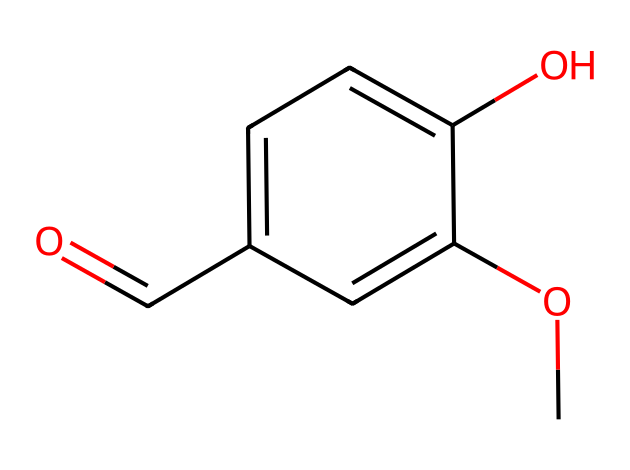What is the molecular formula of vanillin? By analyzing the chemical structure represented in the SMILES notation, we can identify the elements present: carbon (C), hydrogen (H), and oxygen (O). Counting the individual atoms, we find 8 carbon atoms, 8 hydrogen atoms, and 3 oxygen atoms, resulting in the molecular formula C8H8O3.
Answer: C8H8O3 How many aromatic rings are present in vanillin? Looking at the chemical structure, there is one distinct ring that contains alternating double bonds, which indicates it is an aromatic ring.
Answer: 1 What functional groups are present in vanillin? The SMILES representation indicates the presence of a methoxy group (–OCH3) and a hydroxyl group (–OH), both of which are characteristic functional groups found in the chemical structure of vanillin.
Answer: methoxy and hydroxyl What is the significance of the aldehyde group in vanillin? The presence of the aldehyde group (–CHO) contributes to the flavor profile by providing a sweet and creamy character, which is crucial for its use as a flavoring agent in food products.
Answer: flavor profile Can vanillin undergo oxidation? Yes, the aldehyde group in vanillin can be oxidized to a carboxylic acid, confirming that vanillin has the ability to undergo oxidation reactions.
Answer: Yes What type of compound is vanillin primarily used as? Vanillin is primarily used as a flavor compound because of its sweet and pleasant aroma, making it a commonly used ingredient in food and fragrance formulations.
Answer: flavor compound What is the role of vanillin in food products? Vanillin acts as a flavor enhancer, contributing to the overall taste and aroma of a variety of food items, such as desserts and baked goods, thereby enhancing consumer enjoyment.
Answer: flavor enhancer 